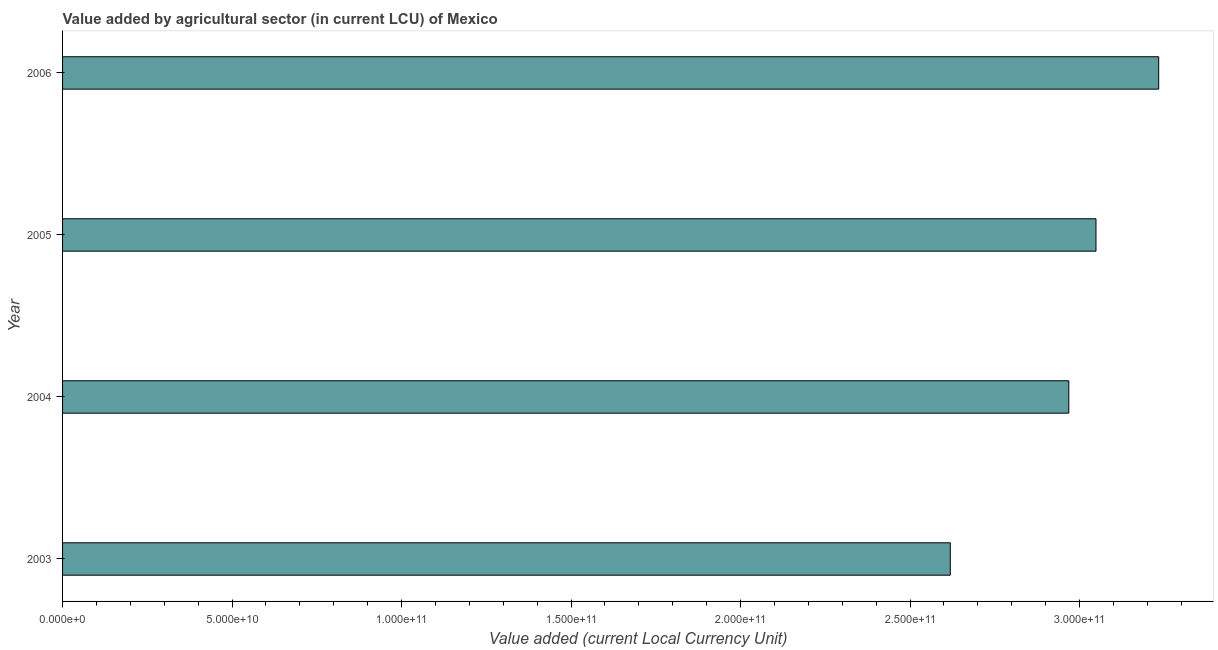Does the graph contain grids?
Make the answer very short. No. What is the title of the graph?
Give a very brief answer. Value added by agricultural sector (in current LCU) of Mexico. What is the label or title of the X-axis?
Your answer should be compact. Value added (current Local Currency Unit). What is the value added by agriculture sector in 2004?
Your response must be concise. 2.97e+11. Across all years, what is the maximum value added by agriculture sector?
Your answer should be very brief. 3.23e+11. Across all years, what is the minimum value added by agriculture sector?
Give a very brief answer. 2.62e+11. What is the sum of the value added by agriculture sector?
Your response must be concise. 1.19e+12. What is the difference between the value added by agriculture sector in 2005 and 2006?
Provide a succinct answer. -1.85e+1. What is the average value added by agriculture sector per year?
Provide a short and direct response. 2.97e+11. What is the median value added by agriculture sector?
Provide a succinct answer. 3.01e+11. Do a majority of the years between 2004 and 2005 (inclusive) have value added by agriculture sector greater than 50000000000 LCU?
Your answer should be compact. Yes. What is the ratio of the value added by agriculture sector in 2003 to that in 2006?
Make the answer very short. 0.81. Is the value added by agriculture sector in 2003 less than that in 2005?
Offer a terse response. Yes. What is the difference between the highest and the second highest value added by agriculture sector?
Keep it short and to the point. 1.85e+1. What is the difference between the highest and the lowest value added by agriculture sector?
Your response must be concise. 6.15e+1. How many bars are there?
Offer a very short reply. 4. What is the difference between two consecutive major ticks on the X-axis?
Provide a succinct answer. 5.00e+1. What is the Value added (current Local Currency Unit) in 2003?
Your answer should be very brief. 2.62e+11. What is the Value added (current Local Currency Unit) in 2004?
Your answer should be very brief. 2.97e+11. What is the Value added (current Local Currency Unit) of 2005?
Your answer should be very brief. 3.05e+11. What is the Value added (current Local Currency Unit) of 2006?
Your response must be concise. 3.23e+11. What is the difference between the Value added (current Local Currency Unit) in 2003 and 2004?
Give a very brief answer. -3.50e+1. What is the difference between the Value added (current Local Currency Unit) in 2003 and 2005?
Offer a terse response. -4.30e+1. What is the difference between the Value added (current Local Currency Unit) in 2003 and 2006?
Ensure brevity in your answer.  -6.15e+1. What is the difference between the Value added (current Local Currency Unit) in 2004 and 2005?
Ensure brevity in your answer.  -8.01e+09. What is the difference between the Value added (current Local Currency Unit) in 2004 and 2006?
Give a very brief answer. -2.65e+1. What is the difference between the Value added (current Local Currency Unit) in 2005 and 2006?
Keep it short and to the point. -1.85e+1. What is the ratio of the Value added (current Local Currency Unit) in 2003 to that in 2004?
Your response must be concise. 0.88. What is the ratio of the Value added (current Local Currency Unit) in 2003 to that in 2005?
Provide a short and direct response. 0.86. What is the ratio of the Value added (current Local Currency Unit) in 2003 to that in 2006?
Keep it short and to the point. 0.81. What is the ratio of the Value added (current Local Currency Unit) in 2004 to that in 2006?
Offer a very short reply. 0.92. What is the ratio of the Value added (current Local Currency Unit) in 2005 to that in 2006?
Give a very brief answer. 0.94. 